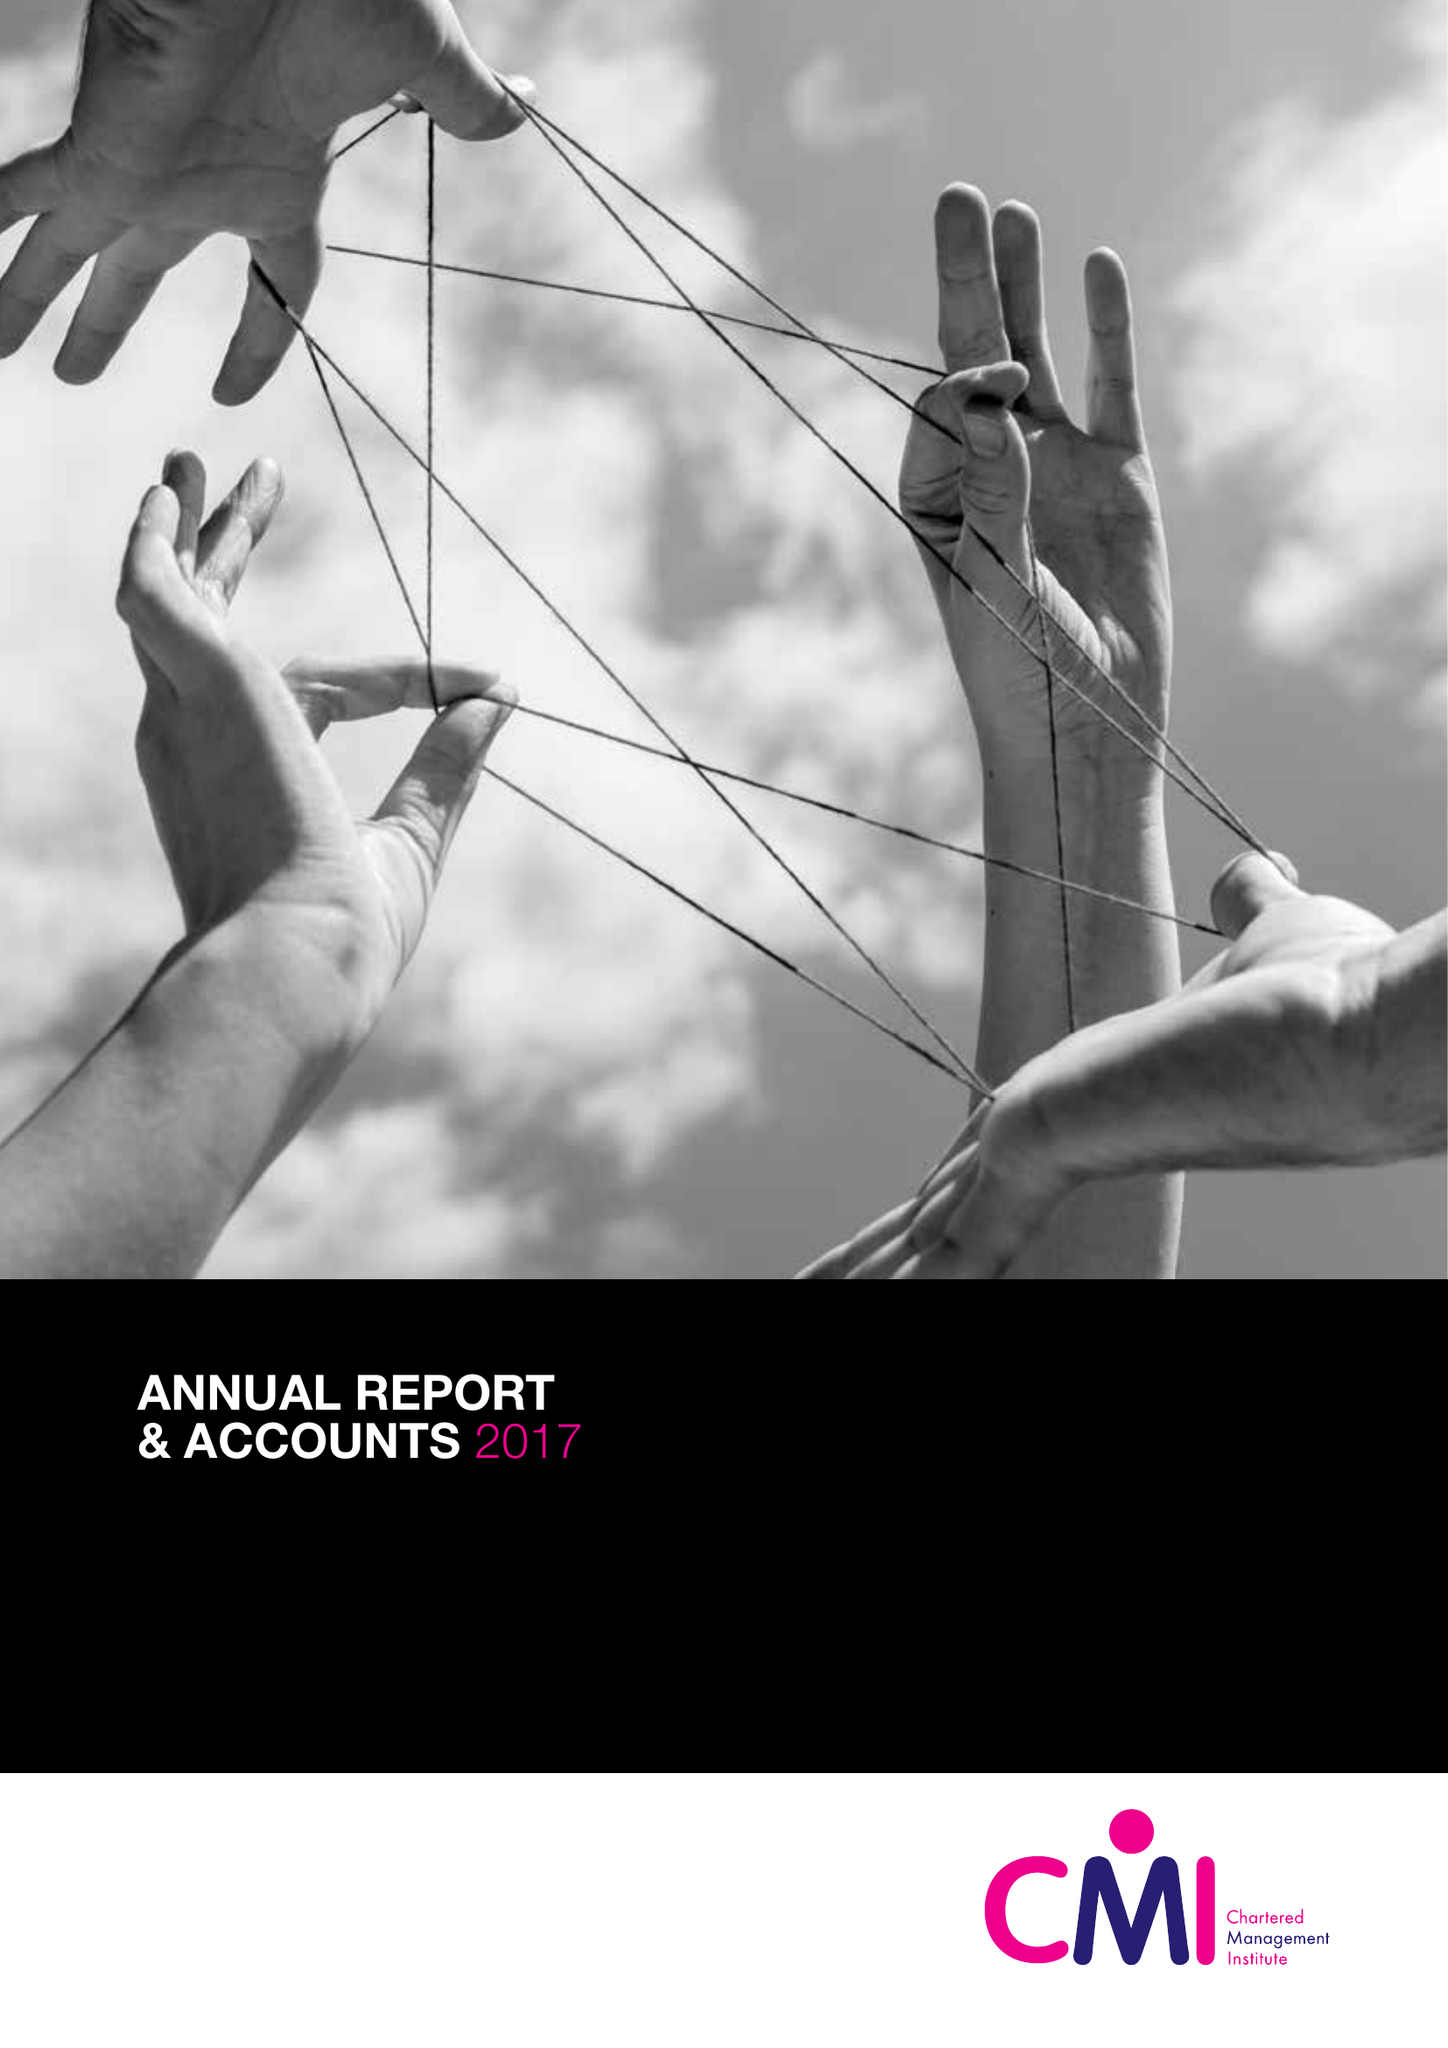What is the value for the spending_annually_in_british_pounds?
Answer the question using a single word or phrase. 12873000.00 